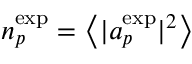<formula> <loc_0><loc_0><loc_500><loc_500>n _ { p } ^ { e x p } = \left < | a _ { p } ^ { e x p } | ^ { 2 } \right ></formula> 